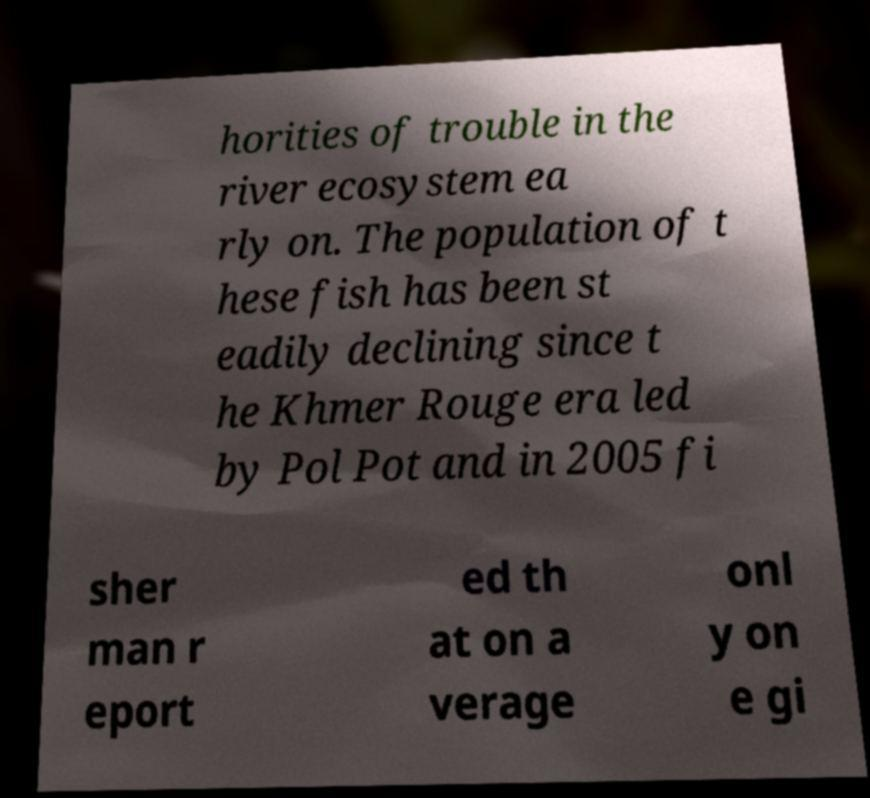For documentation purposes, I need the text within this image transcribed. Could you provide that? horities of trouble in the river ecosystem ea rly on. The population of t hese fish has been st eadily declining since t he Khmer Rouge era led by Pol Pot and in 2005 fi sher man r eport ed th at on a verage onl y on e gi 